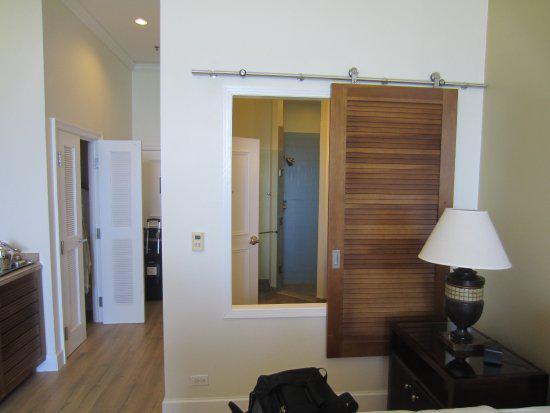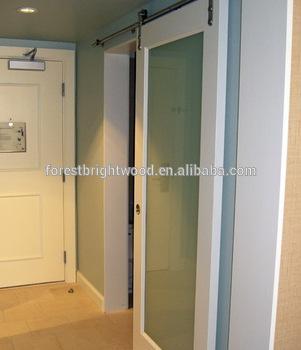The first image is the image on the left, the second image is the image on the right. Evaluate the accuracy of this statement regarding the images: "In at least one image there is a single hanging wooden door.". Is it true? Answer yes or no. Yes. The first image is the image on the left, the second image is the image on the right. Given the left and right images, does the statement "One image shows a sliding door wardrobe that sits against a wall and has two dark wood sections and one section that is not dark." hold true? Answer yes or no. No. 